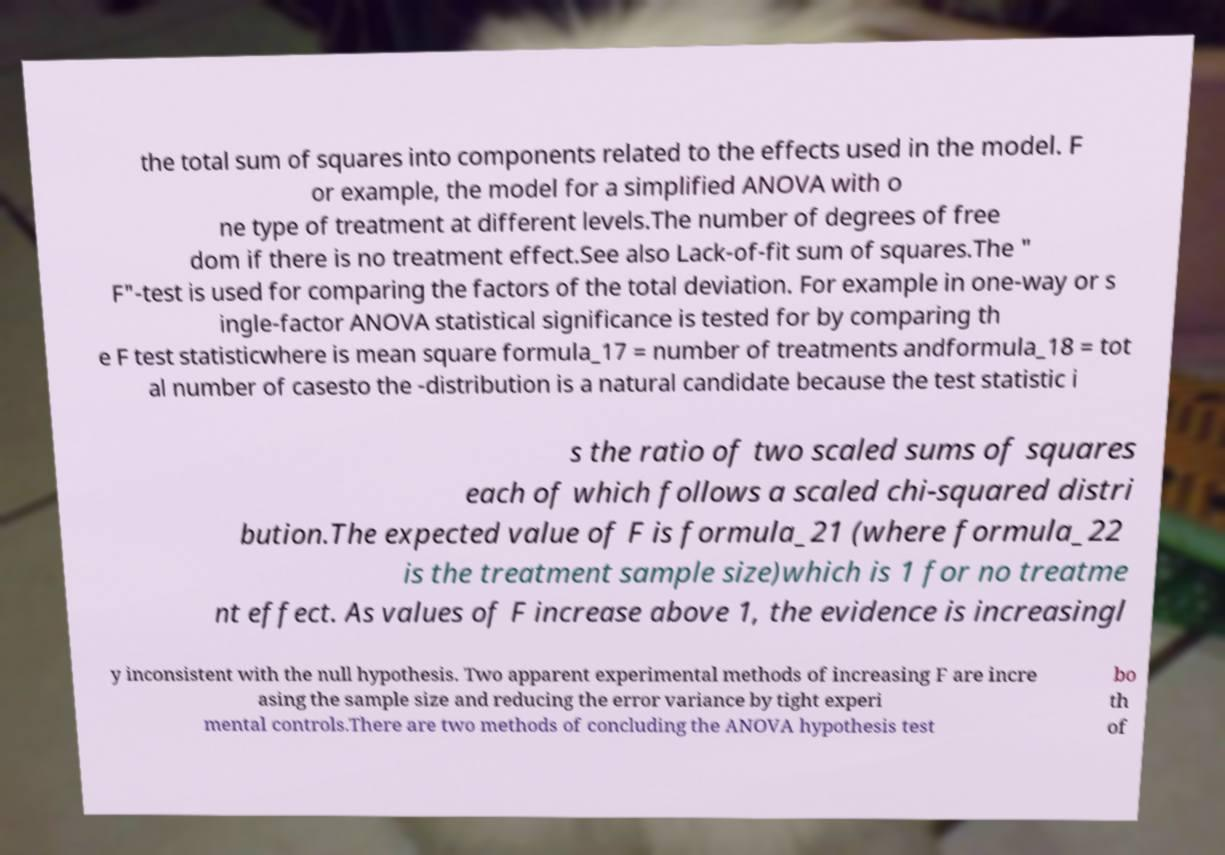I need the written content from this picture converted into text. Can you do that? the total sum of squares into components related to the effects used in the model. F or example, the model for a simplified ANOVA with o ne type of treatment at different levels.The number of degrees of free dom if there is no treatment effect.See also Lack-of-fit sum of squares.The " F"-test is used for comparing the factors of the total deviation. For example in one-way or s ingle-factor ANOVA statistical significance is tested for by comparing th e F test statisticwhere is mean square formula_17 = number of treatments andformula_18 = tot al number of casesto the -distribution is a natural candidate because the test statistic i s the ratio of two scaled sums of squares each of which follows a scaled chi-squared distri bution.The expected value of F is formula_21 (where formula_22 is the treatment sample size)which is 1 for no treatme nt effect. As values of F increase above 1, the evidence is increasingl y inconsistent with the null hypothesis. Two apparent experimental methods of increasing F are incre asing the sample size and reducing the error variance by tight experi mental controls.There are two methods of concluding the ANOVA hypothesis test bo th of 